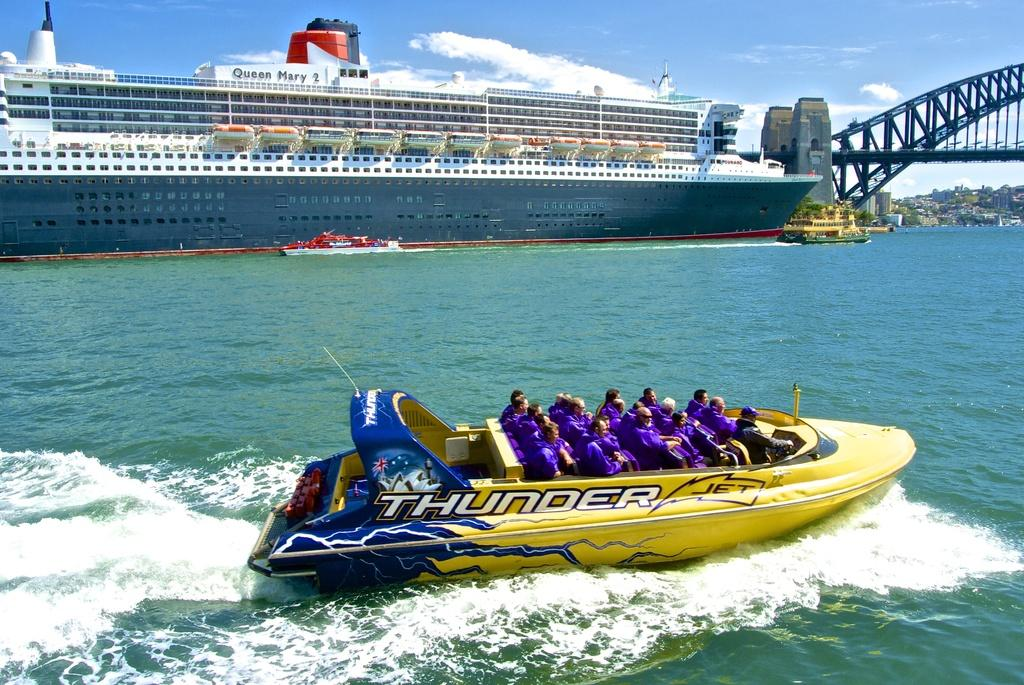<image>
Render a clear and concise summary of the photo. A big yellow boat named Thunder Jet goes across the water carrying many people in blue shirts. 